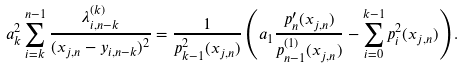<formula> <loc_0><loc_0><loc_500><loc_500>a _ { k } ^ { 2 } \sum _ { i = k } ^ { n - 1 } \frac { \lambda _ { i , n - k } ^ { ( k ) } } { ( x _ { j , n } - y _ { i , n - k } ) ^ { 2 } } = \frac { 1 } { p _ { k - 1 } ^ { 2 } ( x _ { j , n } ) } \left ( a _ { 1 } \frac { p _ { n } ^ { \prime } ( x _ { j , n } ) } { p _ { n - 1 } ^ { ( 1 ) } ( x _ { j , n } ) } - \sum _ { i = 0 } ^ { k - 1 } p _ { i } ^ { 2 } ( x _ { j , n } ) \right ) .</formula> 